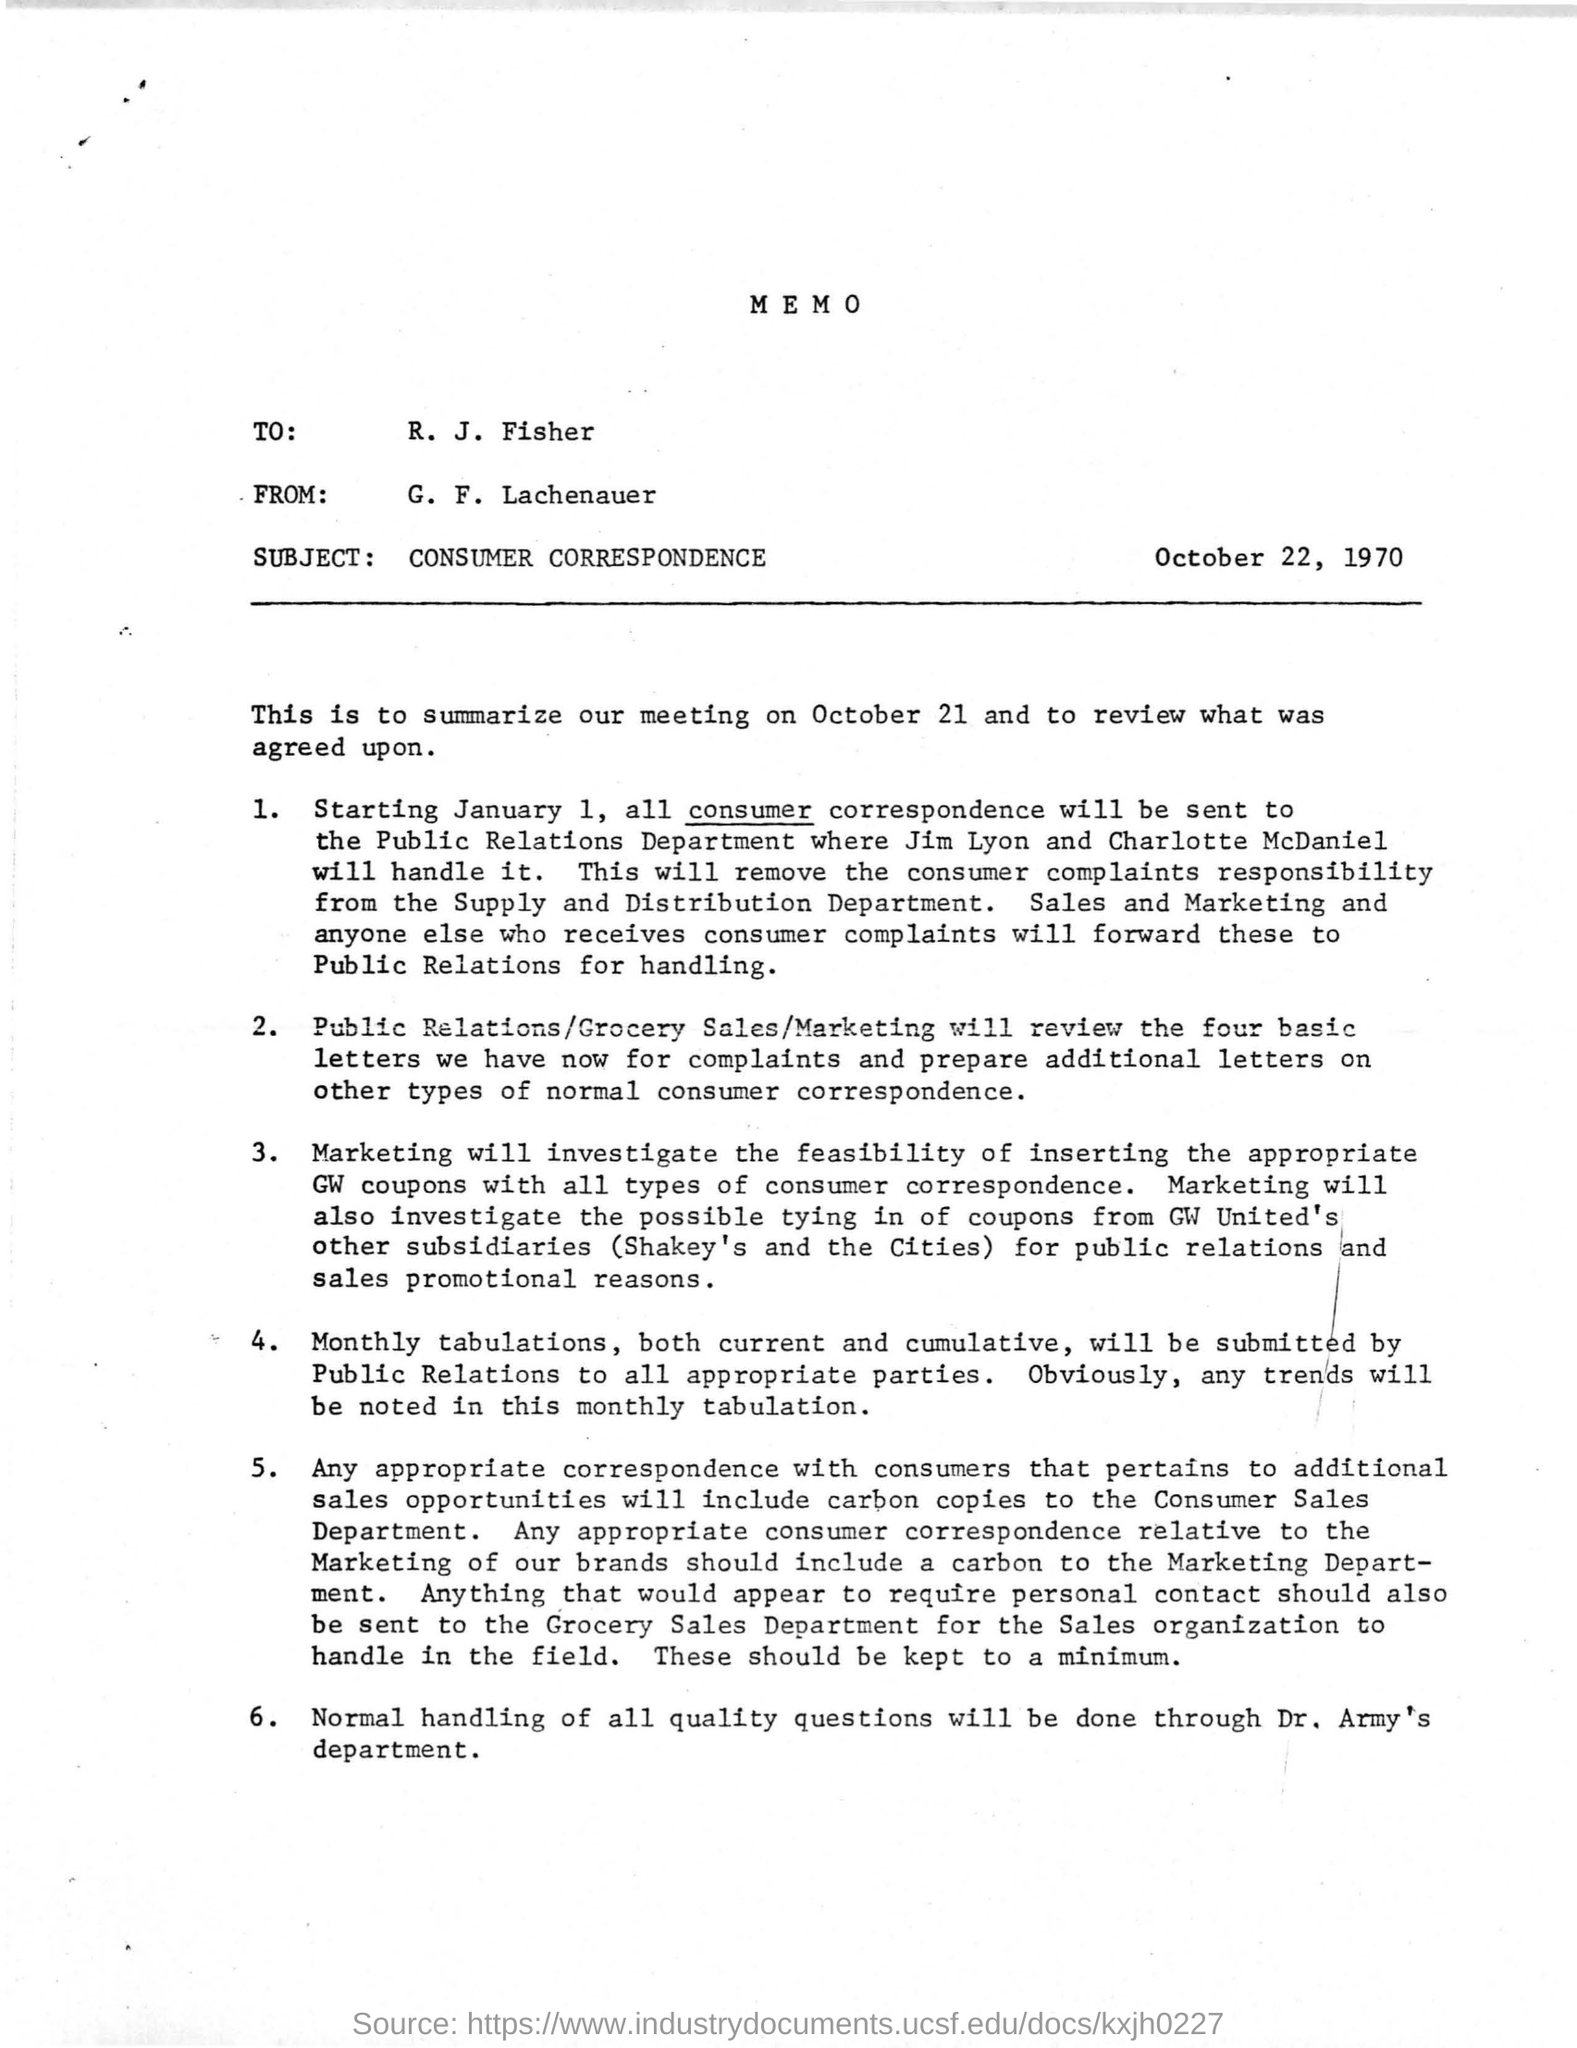What is the subject of the memo?
Your answer should be compact. CONSUMER CORRESPONDENCE. When is the memo dated on?
Your answer should be very brief. October 22, 1970. 